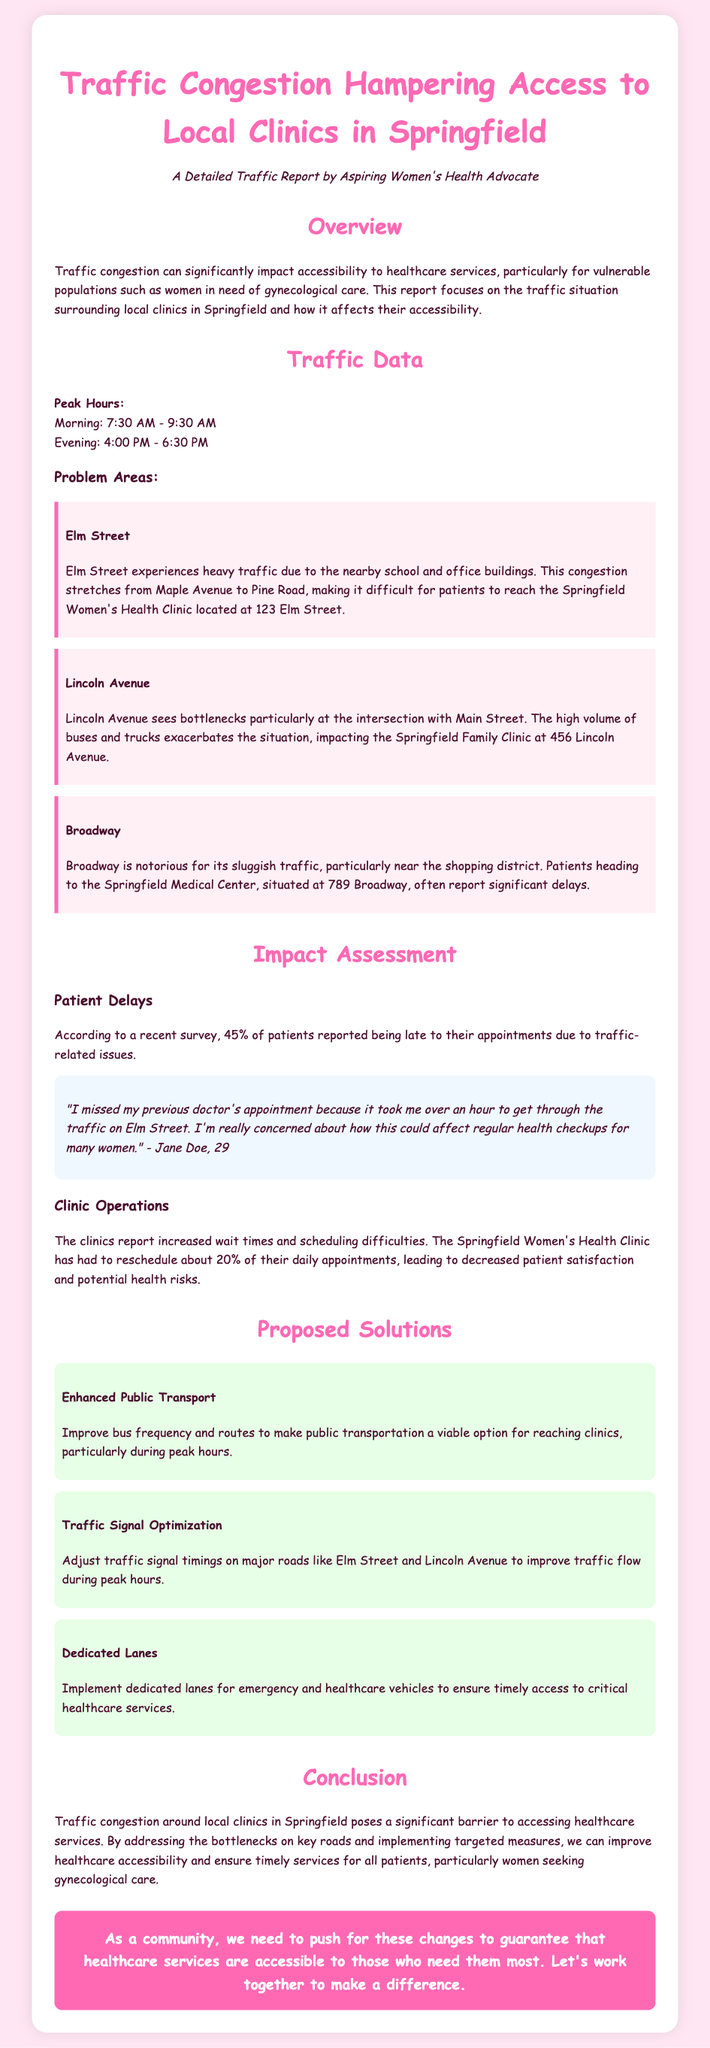What is the title of the report? The title of the report is displayed prominently at the top of the document, indicating the main focus.
Answer: Traffic Congestion Hampering Access to Local Clinics in Springfield What percentage of patients reported being late to appointments? The document includes a statistic on patient delays provided in the impact assessment section.
Answer: 45% What is one of the problem areas listed in the report? The report describes specific problem areas where traffic congestion affects clinic access.
Answer: Elm Street What solution is proposed for improving public transport? The report suggests specific measures to enhance access to healthcare services in the proposed solutions section.
Answer: Improve bus frequency and routes What time does evening peak traffic occur? The document outlines specific peak hours for traffic that hinder healthcare access.
Answer: 4:00 PM - 6:30 PM How many daily appointments does the Springfield Women's Health Clinic have to reschedule due to traffic? A statistic regarding the clinic's operations in relation to traffic congestion is provided in the impact assessment section.
Answer: 20% What color is used for the report's background? The document describes the design choices used in the report that contribute to its visual appeal.
Answer: Light pink How does Broadway affect patient access? The report highlights the specific difficulties faced by patients traveling to a clinic due to traffic conditions.
Answer: Significant delays 